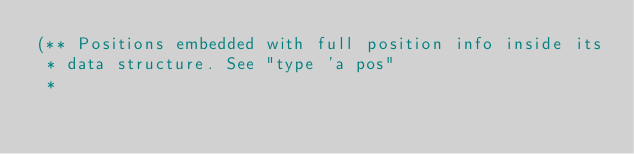Convert code to text. <code><loc_0><loc_0><loc_500><loc_500><_OCaml_>(** Positions embedded with full position info inside its
 * data structure. See "type 'a pos"
 *</code> 